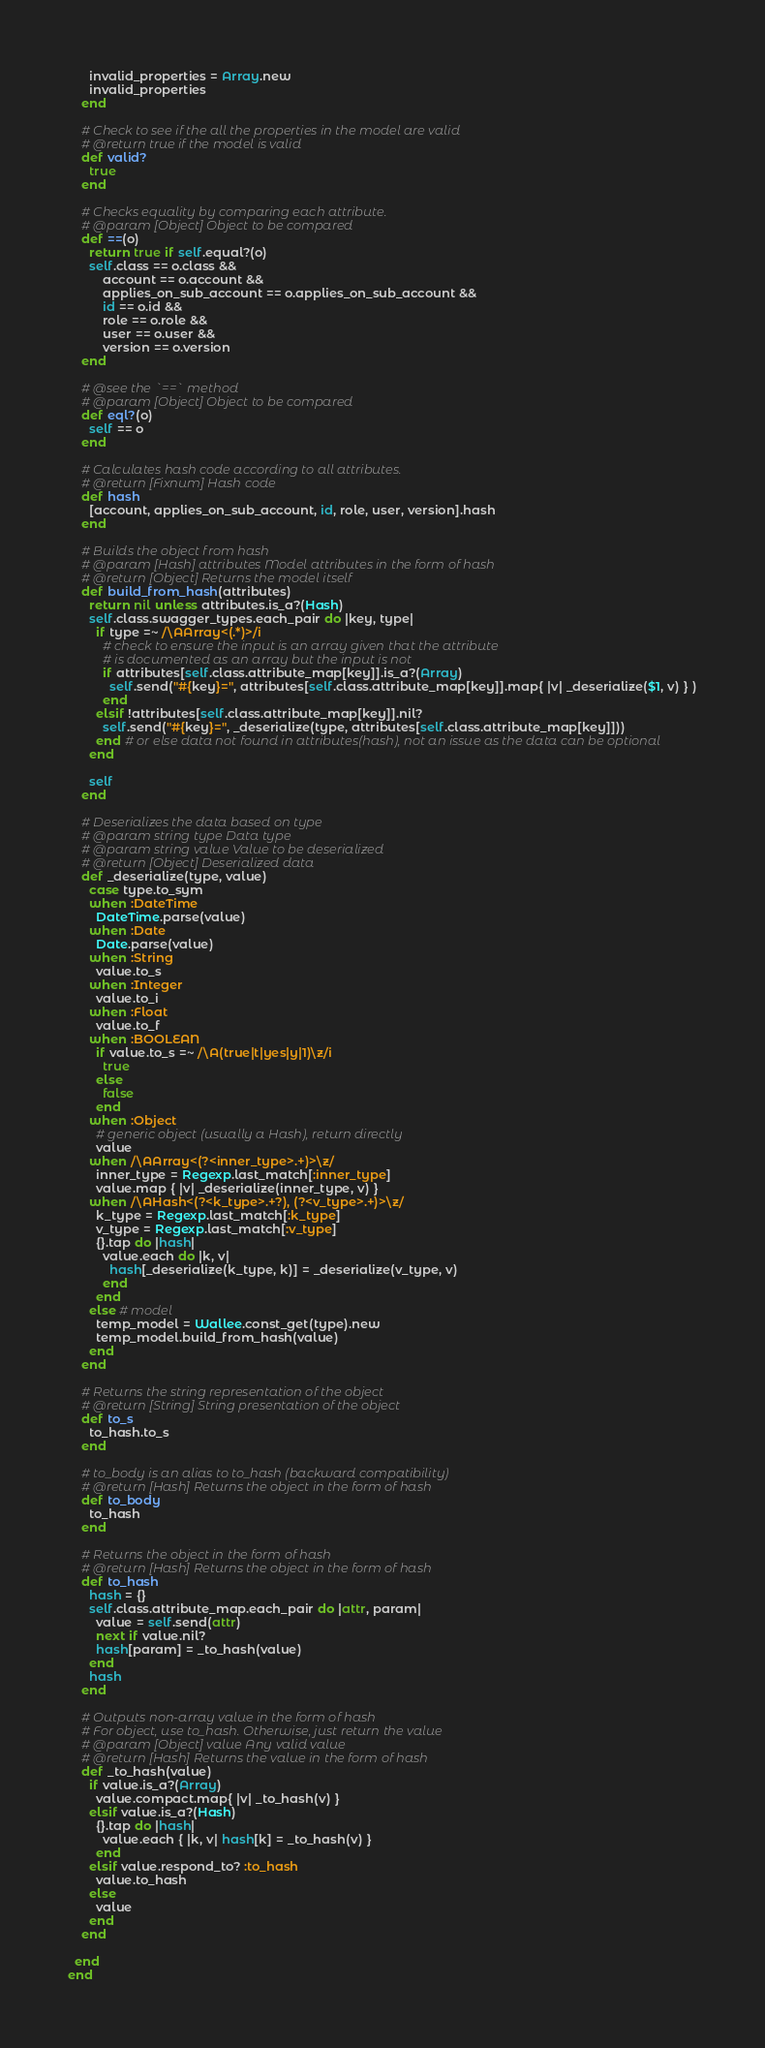Convert code to text. <code><loc_0><loc_0><loc_500><loc_500><_Ruby_>      invalid_properties = Array.new
      invalid_properties
    end

    # Check to see if the all the properties in the model are valid
    # @return true if the model is valid
    def valid?
      true
    end

    # Checks equality by comparing each attribute.
    # @param [Object] Object to be compared
    def ==(o)
      return true if self.equal?(o)
      self.class == o.class &&
          account == o.account &&
          applies_on_sub_account == o.applies_on_sub_account &&
          id == o.id &&
          role == o.role &&
          user == o.user &&
          version == o.version
    end

    # @see the `==` method
    # @param [Object] Object to be compared
    def eql?(o)
      self == o
    end

    # Calculates hash code according to all attributes.
    # @return [Fixnum] Hash code
    def hash
      [account, applies_on_sub_account, id, role, user, version].hash
    end

    # Builds the object from hash
    # @param [Hash] attributes Model attributes in the form of hash
    # @return [Object] Returns the model itself
    def build_from_hash(attributes)
      return nil unless attributes.is_a?(Hash)
      self.class.swagger_types.each_pair do |key, type|
        if type =~ /\AArray<(.*)>/i
          # check to ensure the input is an array given that the attribute
          # is documented as an array but the input is not
          if attributes[self.class.attribute_map[key]].is_a?(Array)
            self.send("#{key}=", attributes[self.class.attribute_map[key]].map{ |v| _deserialize($1, v) } )
          end
        elsif !attributes[self.class.attribute_map[key]].nil?
          self.send("#{key}=", _deserialize(type, attributes[self.class.attribute_map[key]]))
        end # or else data not found in attributes(hash), not an issue as the data can be optional
      end

      self
    end

    # Deserializes the data based on type
    # @param string type Data type
    # @param string value Value to be deserialized
    # @return [Object] Deserialized data
    def _deserialize(type, value)
      case type.to_sym
      when :DateTime
        DateTime.parse(value)
      when :Date
        Date.parse(value)
      when :String
        value.to_s
      when :Integer
        value.to_i
      when :Float
        value.to_f
      when :BOOLEAN
        if value.to_s =~ /\A(true|t|yes|y|1)\z/i
          true
        else
          false
        end
      when :Object
        # generic object (usually a Hash), return directly
        value
      when /\AArray<(?<inner_type>.+)>\z/
        inner_type = Regexp.last_match[:inner_type]
        value.map { |v| _deserialize(inner_type, v) }
      when /\AHash<(?<k_type>.+?), (?<v_type>.+)>\z/
        k_type = Regexp.last_match[:k_type]
        v_type = Regexp.last_match[:v_type]
        {}.tap do |hash|
          value.each do |k, v|
            hash[_deserialize(k_type, k)] = _deserialize(v_type, v)
          end
        end
      else # model
        temp_model = Wallee.const_get(type).new
        temp_model.build_from_hash(value)
      end
    end

    # Returns the string representation of the object
    # @return [String] String presentation of the object
    def to_s
      to_hash.to_s
    end

    # to_body is an alias to to_hash (backward compatibility)
    # @return [Hash] Returns the object in the form of hash
    def to_body
      to_hash
    end

    # Returns the object in the form of hash
    # @return [Hash] Returns the object in the form of hash
    def to_hash
      hash = {}
      self.class.attribute_map.each_pair do |attr, param|
        value = self.send(attr)
        next if value.nil?
        hash[param] = _to_hash(value)
      end
      hash
    end

    # Outputs non-array value in the form of hash
    # For object, use to_hash. Otherwise, just return the value
    # @param [Object] value Any valid value
    # @return [Hash] Returns the value in the form of hash
    def _to_hash(value)
      if value.is_a?(Array)
        value.compact.map{ |v| _to_hash(v) }
      elsif value.is_a?(Hash)
        {}.tap do |hash|
          value.each { |k, v| hash[k] = _to_hash(v) }
        end
      elsif value.respond_to? :to_hash
        value.to_hash
      else
        value
      end
    end

  end
end
</code> 